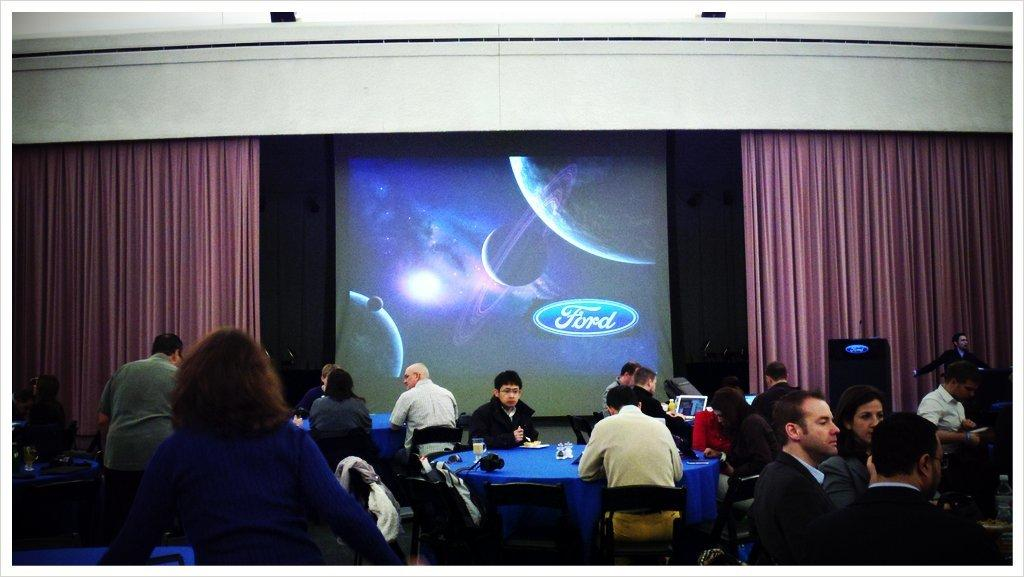What are the people in the image doing? The people in the image are seated on chairs. What objects can be seen in the image besides the people? There are tables, a screen, curtains, a glass, and a plate with food in the image. What is the man in the image doing? There is a man standing in the image. What channel is the man watching on the screen in the image? There is no information about the man watching a screen or a specific channel in the image. 